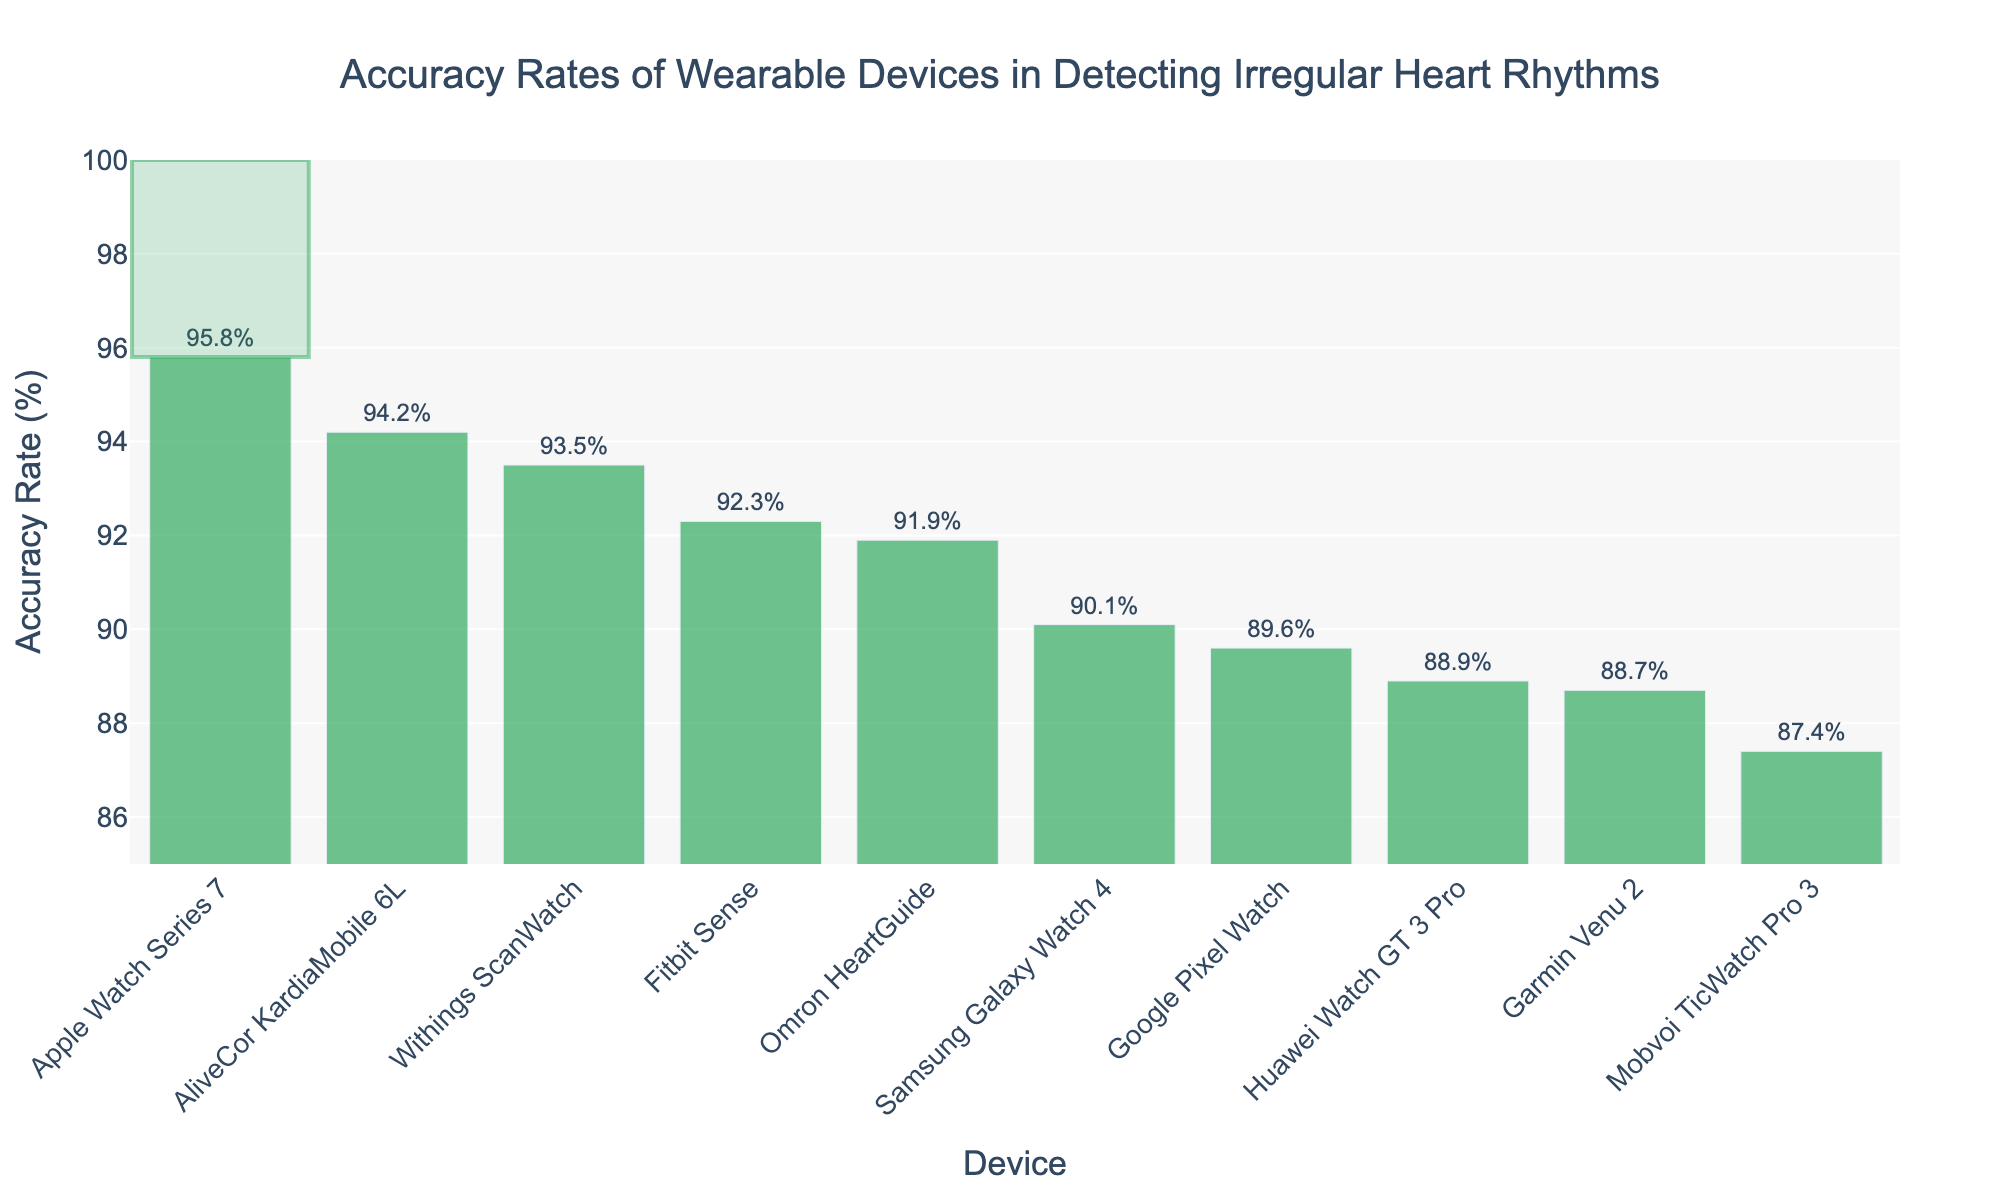Which device has the highest accuracy rate in detecting irregular heart rhythms? The figure shows a bar chart with the accuracy rates of different devices. The tallest bar, indicating the highest accuracy, corresponds to the Apple Watch Series 7.
Answer: Apple Watch Series 7 Which device has the lowest accuracy rate? The figure shows a bar chart with the accuracy rates of various devices. The shortest bar, indicating the lowest accuracy, corresponds to the Mobvoi TicWatch Pro 3.
Answer: Mobvoi TicWatch Pro 3 How much higher is the accuracy rate of the Apple Watch Series 7 compared to the Samsung Galaxy Watch 4? The accuracy rate for the Apple Watch Series 7 is 95.8%, and for the Samsung Galaxy Watch 4, it is 90.1%. Subtracting these values gives us 95.8 - 90.1 = 5.7%.
Answer: 5.7% What is the average accuracy rate of all the devices listed? Sum all the accuracy rates: 95.8 + 92.3 + 90.1 + 88.7 + 93.5 + 91.9 + 94.2 + 89.6 + 87.4 + 88.9 = 912.4. There are 10 devices, so the average is 912.4 / 10 = 91.24%.
Answer: 91.24% Which device ranks third in terms of accuracy rate? The devices are sorted by accuracy rate in descending order. The third-highest value corresponds to the third bar from the left, which is the AliveCor KardiaMobile 6L with an accuracy rate of 94.2%.
Answer: AliveCor KardiaMobile 6L How does the accuracy rate of the Withings ScanWatch compare to the Fitbit Sense? The accuracy rate of the Withings ScanWatch is 93.5%, and the accuracy rate of the Fitbit Sense is 92.3%. Comparing these, the Withings ScanWatch has a slightly higher accuracy.
Answer: Withings ScanWatch is higher What is the median accuracy rate of the listed devices? To find the median, list the accuracy rates in ascending order and find the middle value. The ordered list is: 87.4, 88.7, 88.9, 89.6, 90.1, 91.9, 92.3, 93.5, 94.2, 95.8. The median is the average of the 5th and 6th values: (90.1 + 91.9) / 2 = 91.0%.
Answer: 91.0% What is the difference in accuracy rates between the Omron HeartGuide and the Google Pixel Watch? The accuracy rate for the Omron HeartGuide is 91.9%, and for the Google Pixel Watch, it is 89.6%. Subtracting these values gives us 91.9 - 89.6 = 2.3%.
Answer: 2.3% What is the combined accuracy rate of the Fitbit Sense and the Withings ScanWatch? Adding the accuracy rates of the Fitbit Sense (92.3%) and the Withings ScanWatch (93.5%) gives 92.3 + 93.5 = 185.8%.
Answer: 185.8% Which devices have an accuracy rate greater than 90%? From the figure, the bars showing devices with accuracy rates greater than 90% are: Apple Watch Series 7, Fitbit Sense, Withings ScanWatch, Omron HeartGuide, and AliveCor KardiaMobile 6L.
Answer: Apple Watch Series 7, Fitbit Sense, Withings ScanWatch, Omron HeartGuide, AliveCor KardiaMobile 6L 